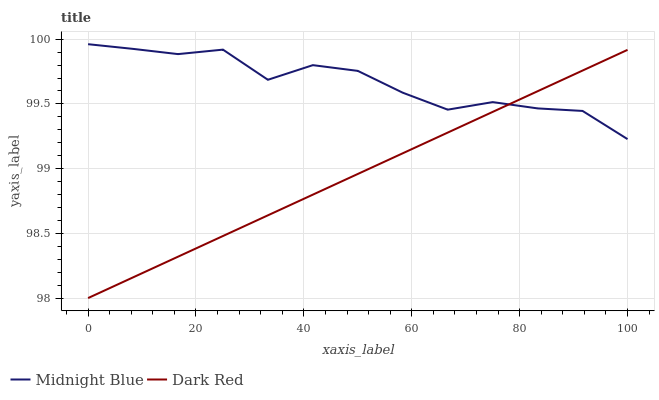Does Dark Red have the minimum area under the curve?
Answer yes or no. Yes. Does Midnight Blue have the maximum area under the curve?
Answer yes or no. Yes. Does Midnight Blue have the minimum area under the curve?
Answer yes or no. No. Is Dark Red the smoothest?
Answer yes or no. Yes. Is Midnight Blue the roughest?
Answer yes or no. Yes. Is Midnight Blue the smoothest?
Answer yes or no. No. Does Dark Red have the lowest value?
Answer yes or no. Yes. Does Midnight Blue have the lowest value?
Answer yes or no. No. Does Midnight Blue have the highest value?
Answer yes or no. Yes. Does Midnight Blue intersect Dark Red?
Answer yes or no. Yes. Is Midnight Blue less than Dark Red?
Answer yes or no. No. Is Midnight Blue greater than Dark Red?
Answer yes or no. No. 